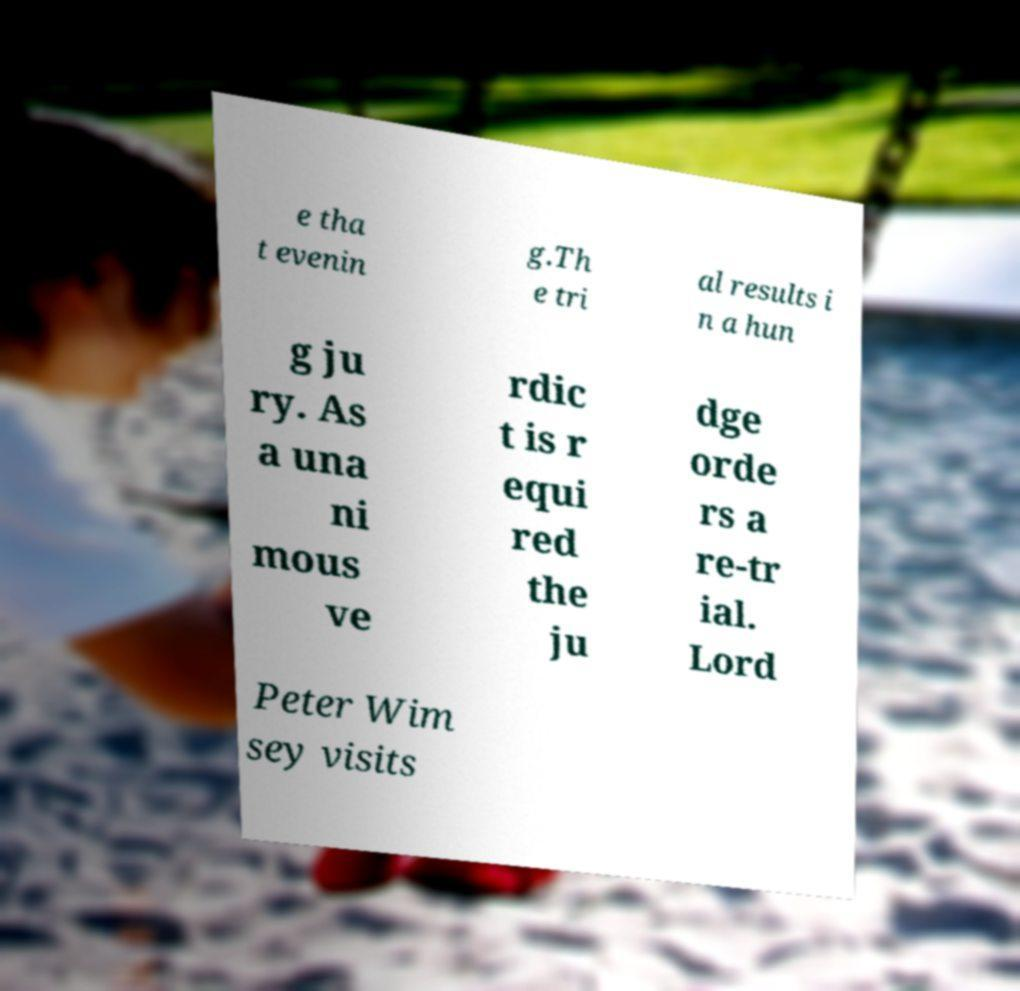There's text embedded in this image that I need extracted. Can you transcribe it verbatim? e tha t evenin g.Th e tri al results i n a hun g ju ry. As a una ni mous ve rdic t is r equi red the ju dge orde rs a re-tr ial. Lord Peter Wim sey visits 